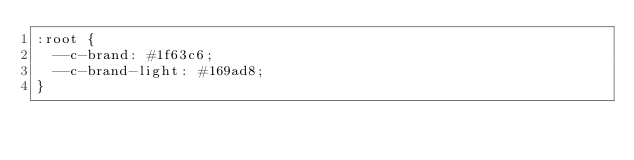<code> <loc_0><loc_0><loc_500><loc_500><_CSS_>:root {
  --c-brand: #1f63c6;
  --c-brand-light: #169ad8;
}
</code> 